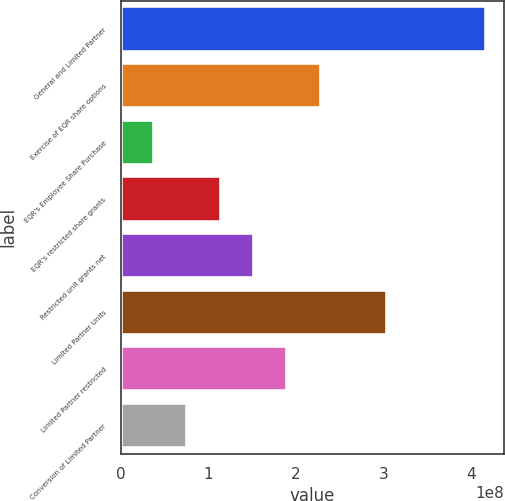Convert chart to OTSL. <chart><loc_0><loc_0><loc_500><loc_500><bar_chart><fcel>General and Limited Partner<fcel>Exercise of EQR share options<fcel>EQR's Employee Share Purchase<fcel>EQR's restricted share grants<fcel>Restricted unit grants net<fcel>Limited Partner Units<fcel>Limited Partner restricted<fcel>Conversion of Limited Partner<nl><fcel>4.17232e+08<fcel>2.28298e+08<fcel>3.80497e+07<fcel>1.14149e+08<fcel>1.52199e+08<fcel>3.04398e+08<fcel>1.90249e+08<fcel>7.60994e+07<nl></chart> 